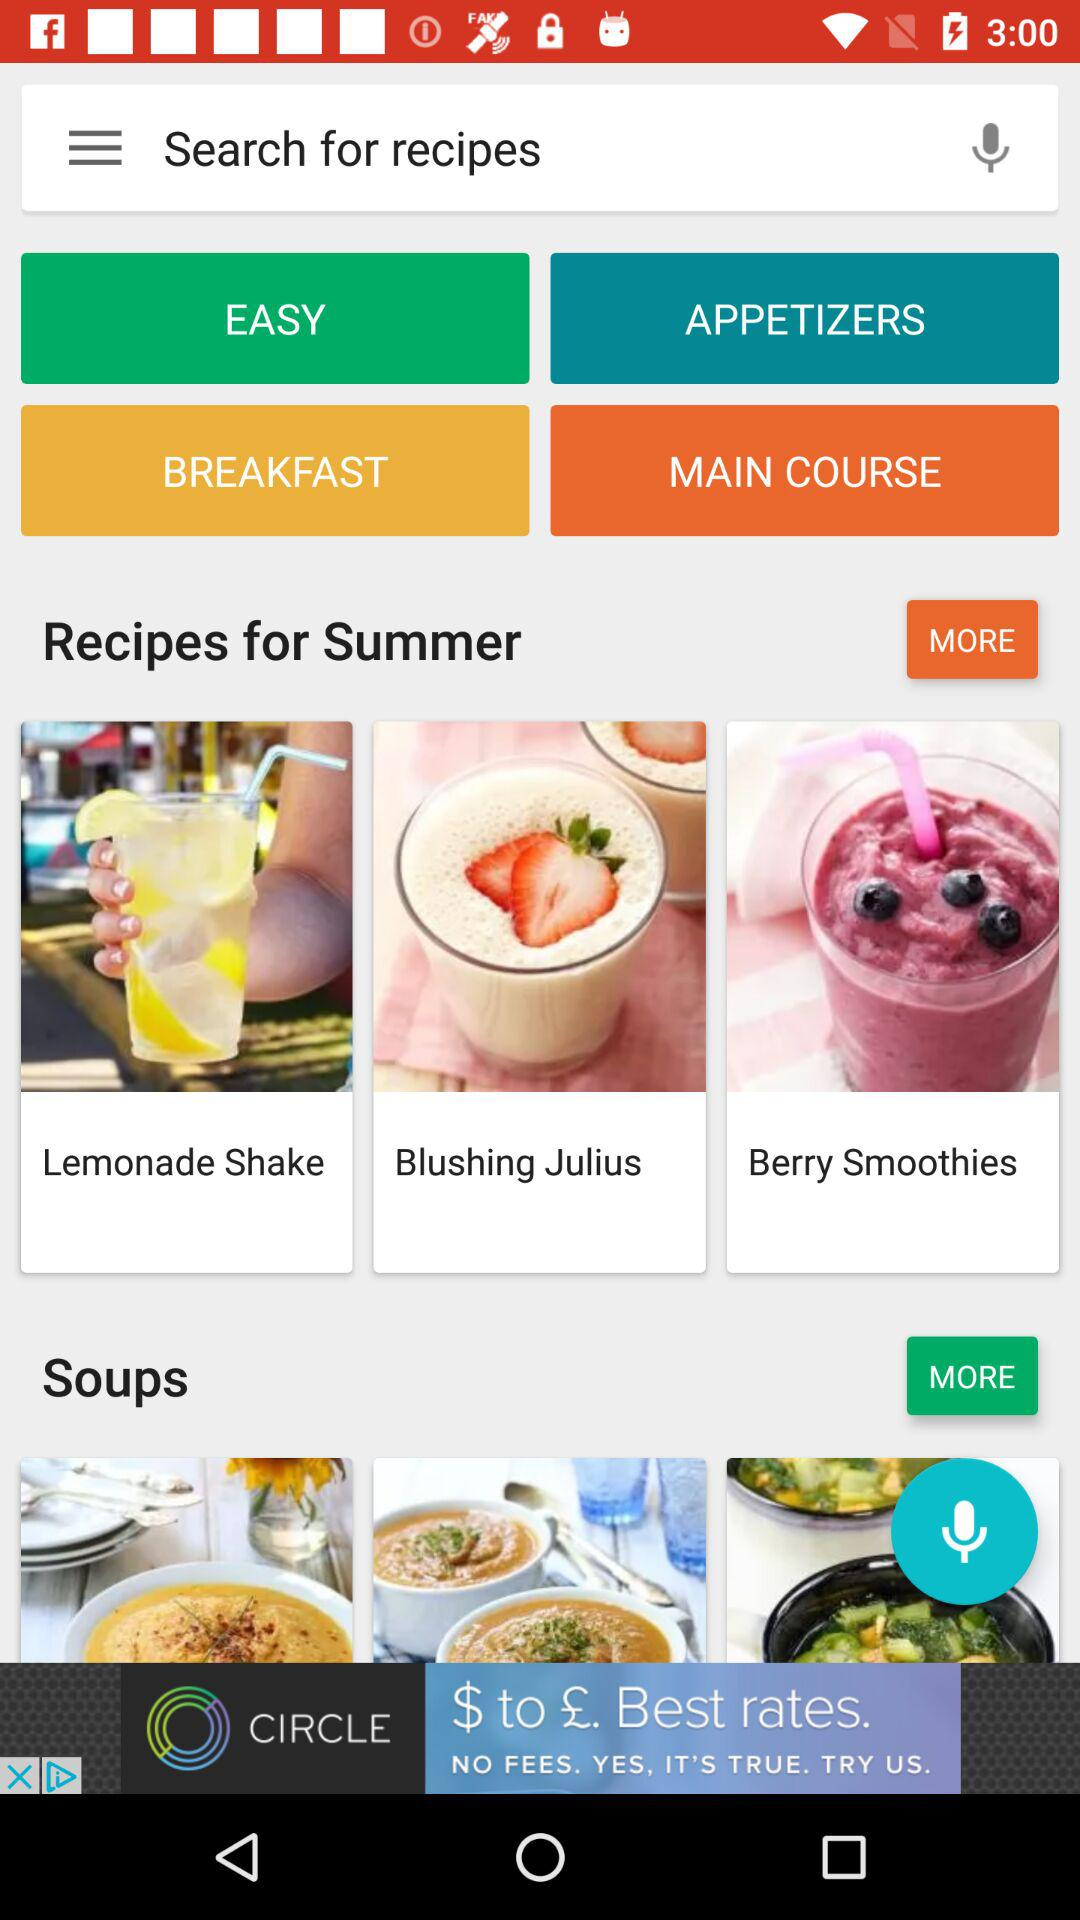How many calories are there in a lemonade shake?
When the provided information is insufficient, respond with <no answer>. <no answer> 